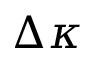Convert formula to latex. <formula><loc_0><loc_0><loc_500><loc_500>\Delta \kappa</formula> 